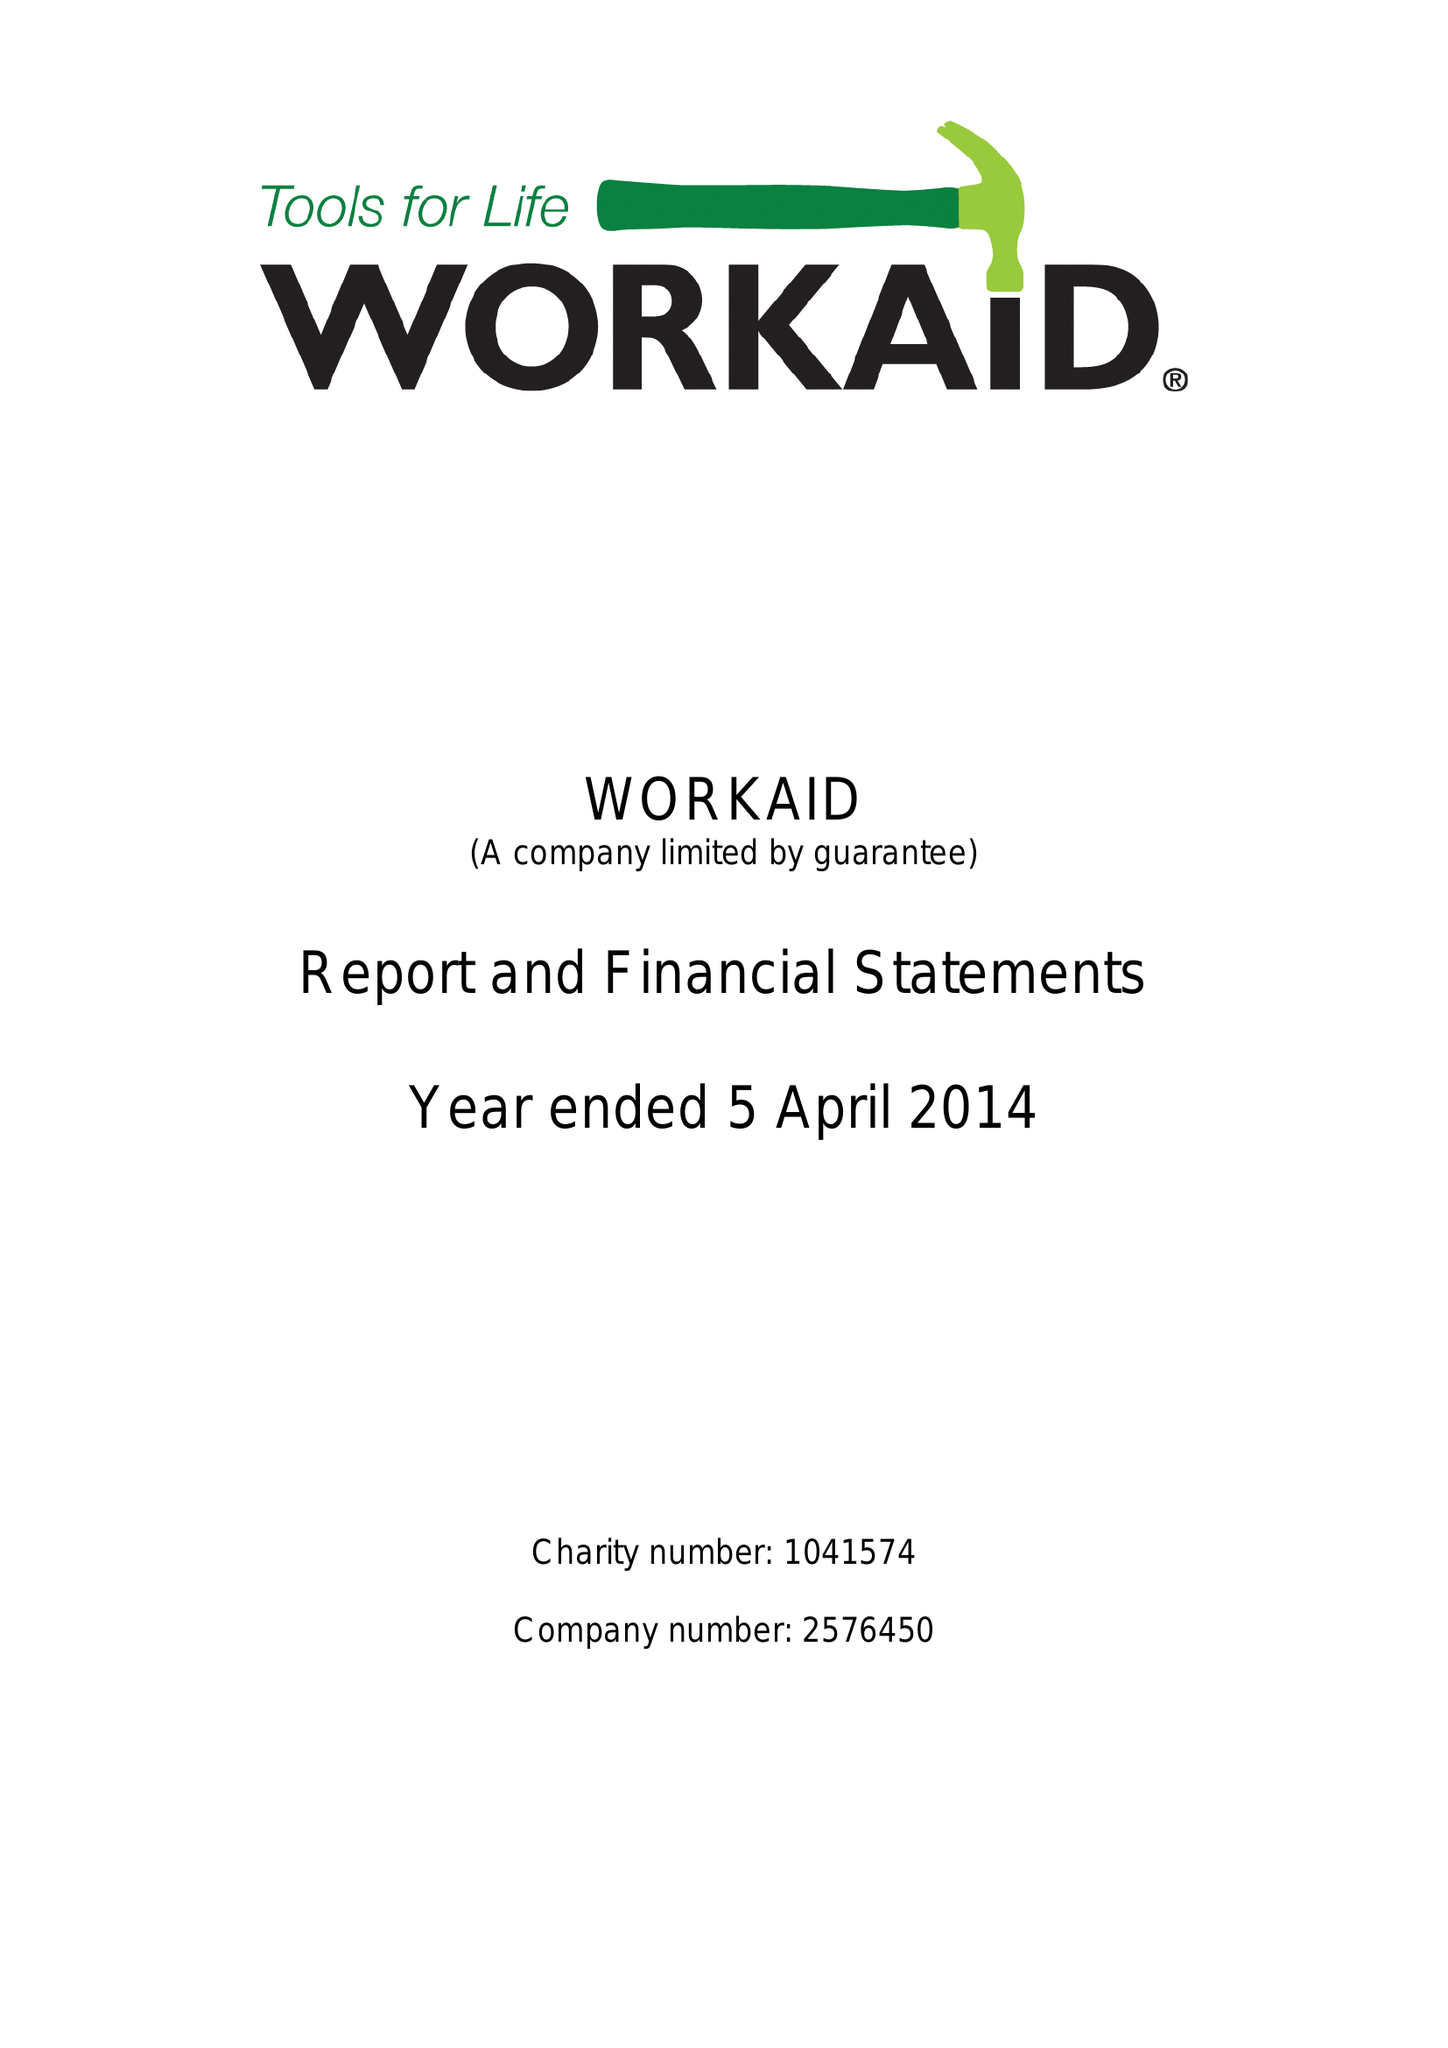What is the value for the charity_number?
Answer the question using a single word or phrase. 1041574 